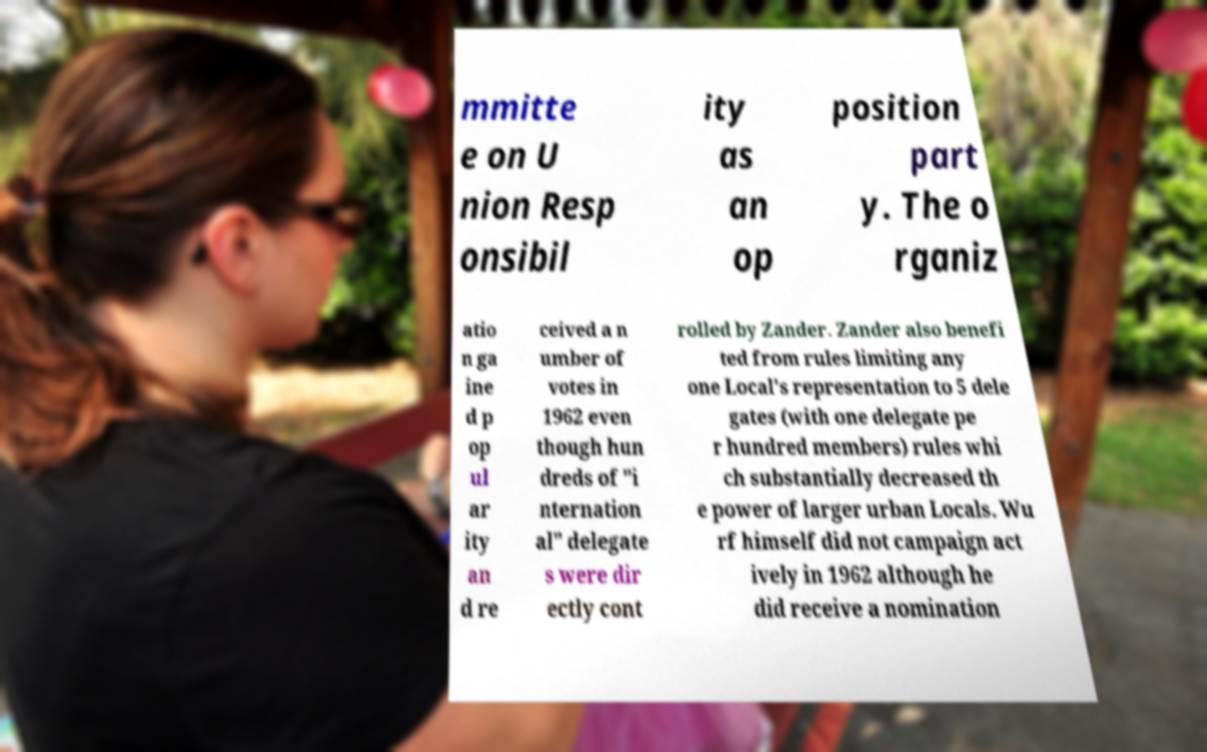Can you accurately transcribe the text from the provided image for me? mmitte e on U nion Resp onsibil ity as an op position part y. The o rganiz atio n ga ine d p op ul ar ity an d re ceived a n umber of votes in 1962 even though hun dreds of "i nternation al" delegate s were dir ectly cont rolled by Zander. Zander also benefi ted from rules limiting any one Local's representation to 5 dele gates (with one delegate pe r hundred members) rules whi ch substantially decreased th e power of larger urban Locals. Wu rf himself did not campaign act ively in 1962 although he did receive a nomination 